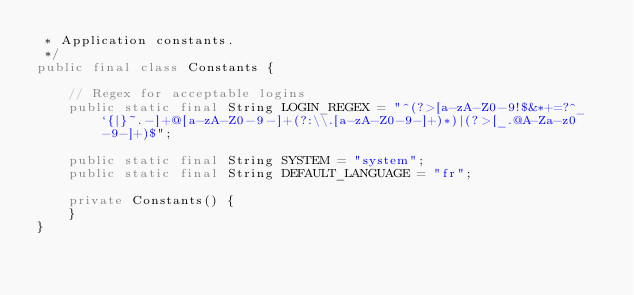<code> <loc_0><loc_0><loc_500><loc_500><_Java_> * Application constants.
 */
public final class Constants {

    // Regex for acceptable logins
    public static final String LOGIN_REGEX = "^(?>[a-zA-Z0-9!$&*+=?^_`{|}~.-]+@[a-zA-Z0-9-]+(?:\\.[a-zA-Z0-9-]+)*)|(?>[_.@A-Za-z0-9-]+)$";

    public static final String SYSTEM = "system";
    public static final String DEFAULT_LANGUAGE = "fr";

    private Constants() {
    }
}
</code> 